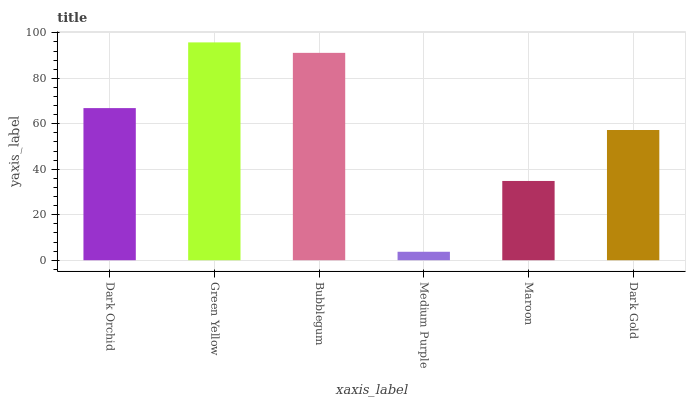Is Bubblegum the minimum?
Answer yes or no. No. Is Bubblegum the maximum?
Answer yes or no. No. Is Green Yellow greater than Bubblegum?
Answer yes or no. Yes. Is Bubblegum less than Green Yellow?
Answer yes or no. Yes. Is Bubblegum greater than Green Yellow?
Answer yes or no. No. Is Green Yellow less than Bubblegum?
Answer yes or no. No. Is Dark Orchid the high median?
Answer yes or no. Yes. Is Dark Gold the low median?
Answer yes or no. Yes. Is Bubblegum the high median?
Answer yes or no. No. Is Bubblegum the low median?
Answer yes or no. No. 